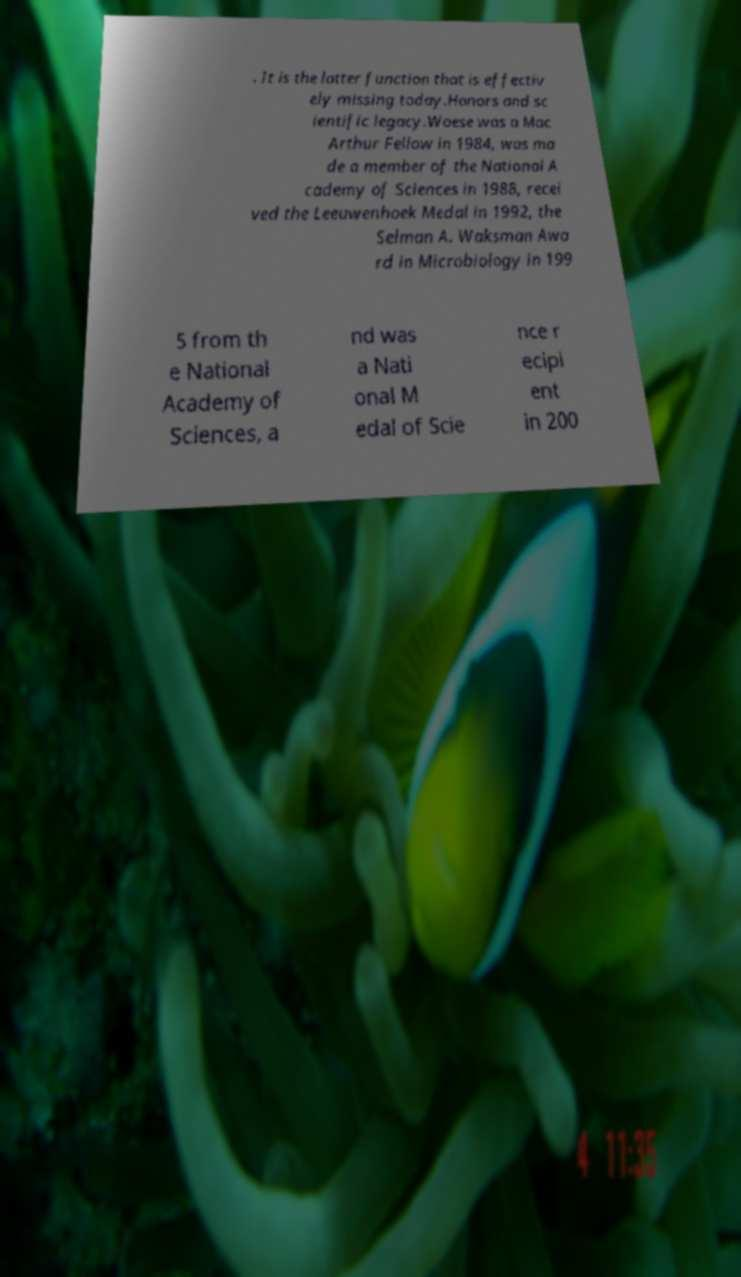There's text embedded in this image that I need extracted. Can you transcribe it verbatim? . It is the latter function that is effectiv ely missing today.Honors and sc ientific legacy.Woese was a Mac Arthur Fellow in 1984, was ma de a member of the National A cademy of Sciences in 1988, recei ved the Leeuwenhoek Medal in 1992, the Selman A. Waksman Awa rd in Microbiology in 199 5 from th e National Academy of Sciences, a nd was a Nati onal M edal of Scie nce r ecipi ent in 200 